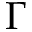<formula> <loc_0><loc_0><loc_500><loc_500>\Gamma</formula> 